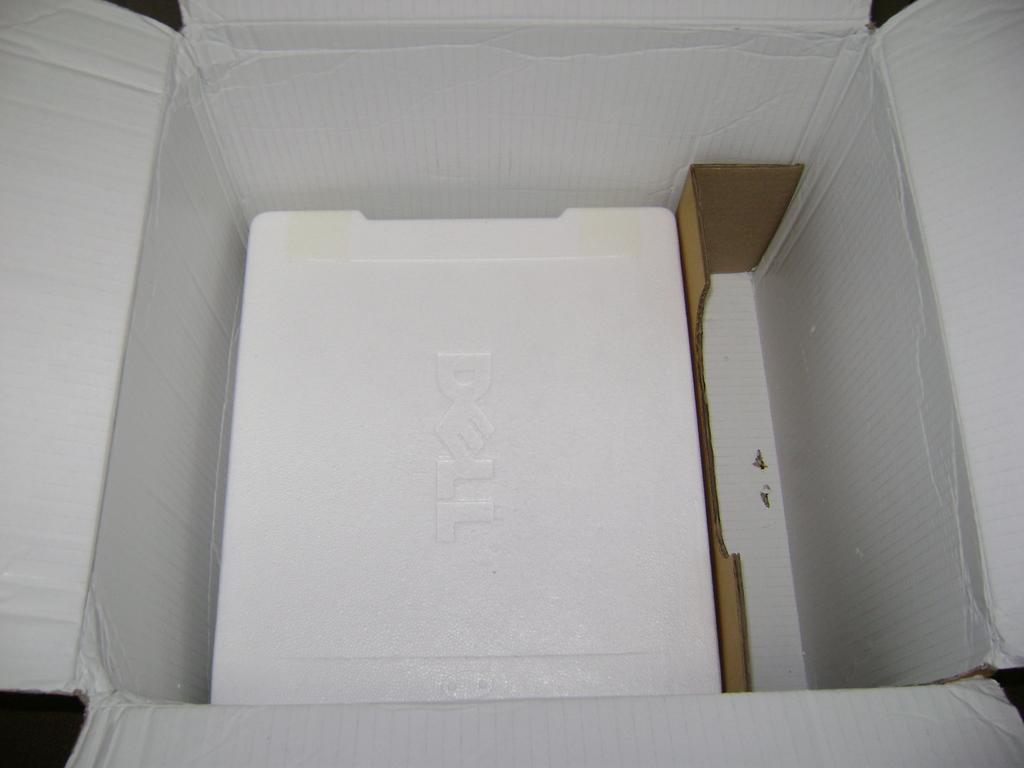<image>
Write a terse but informative summary of the picture. An empty box which at one point contained a Dell computer still have Styrofoam at the bottom of it. 